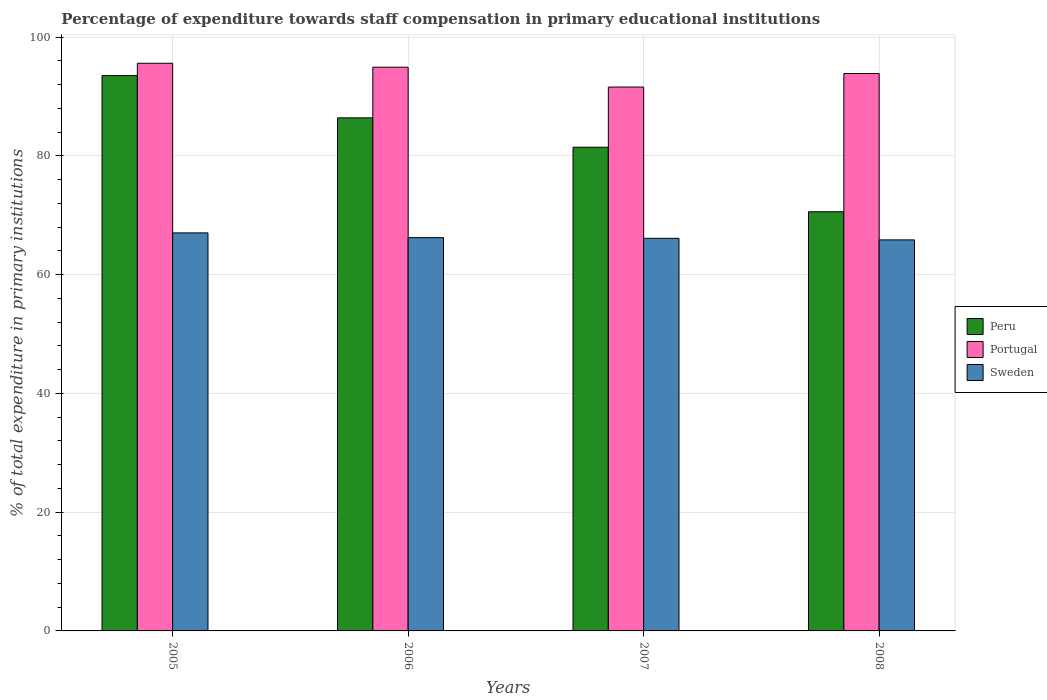How many different coloured bars are there?
Give a very brief answer. 3. Are the number of bars per tick equal to the number of legend labels?
Provide a succinct answer. Yes. Are the number of bars on each tick of the X-axis equal?
Your answer should be very brief. Yes. How many bars are there on the 4th tick from the left?
Keep it short and to the point. 3. What is the percentage of expenditure towards staff compensation in Sweden in 2006?
Ensure brevity in your answer.  66.23. Across all years, what is the maximum percentage of expenditure towards staff compensation in Portugal?
Offer a terse response. 95.6. Across all years, what is the minimum percentage of expenditure towards staff compensation in Sweden?
Offer a terse response. 65.85. In which year was the percentage of expenditure towards staff compensation in Portugal minimum?
Provide a succinct answer. 2007. What is the total percentage of expenditure towards staff compensation in Peru in the graph?
Make the answer very short. 331.96. What is the difference between the percentage of expenditure towards staff compensation in Peru in 2005 and that in 2008?
Make the answer very short. 22.92. What is the difference between the percentage of expenditure towards staff compensation in Sweden in 2008 and the percentage of expenditure towards staff compensation in Portugal in 2006?
Make the answer very short. -29.08. What is the average percentage of expenditure towards staff compensation in Peru per year?
Provide a succinct answer. 82.99. In the year 2005, what is the difference between the percentage of expenditure towards staff compensation in Peru and percentage of expenditure towards staff compensation in Portugal?
Offer a terse response. -2.09. What is the ratio of the percentage of expenditure towards staff compensation in Peru in 2005 to that in 2006?
Ensure brevity in your answer.  1.08. What is the difference between the highest and the second highest percentage of expenditure towards staff compensation in Portugal?
Make the answer very short. 0.66. What is the difference between the highest and the lowest percentage of expenditure towards staff compensation in Portugal?
Give a very brief answer. 4.01. Is the sum of the percentage of expenditure towards staff compensation in Peru in 2005 and 2007 greater than the maximum percentage of expenditure towards staff compensation in Sweden across all years?
Offer a terse response. Yes. What does the 3rd bar from the left in 2005 represents?
Ensure brevity in your answer.  Sweden. Is it the case that in every year, the sum of the percentage of expenditure towards staff compensation in Peru and percentage of expenditure towards staff compensation in Sweden is greater than the percentage of expenditure towards staff compensation in Portugal?
Give a very brief answer. Yes. How many years are there in the graph?
Ensure brevity in your answer.  4. What is the difference between two consecutive major ticks on the Y-axis?
Offer a terse response. 20. Does the graph contain any zero values?
Your response must be concise. No. Where does the legend appear in the graph?
Give a very brief answer. Center right. How many legend labels are there?
Provide a short and direct response. 3. What is the title of the graph?
Provide a short and direct response. Percentage of expenditure towards staff compensation in primary educational institutions. Does "Guinea" appear as one of the legend labels in the graph?
Provide a succinct answer. No. What is the label or title of the X-axis?
Provide a short and direct response. Years. What is the label or title of the Y-axis?
Give a very brief answer. % of total expenditure in primary institutions. What is the % of total expenditure in primary institutions of Peru in 2005?
Make the answer very short. 93.51. What is the % of total expenditure in primary institutions of Portugal in 2005?
Your response must be concise. 95.6. What is the % of total expenditure in primary institutions of Sweden in 2005?
Your response must be concise. 67.03. What is the % of total expenditure in primary institutions in Peru in 2006?
Your answer should be compact. 86.4. What is the % of total expenditure in primary institutions of Portugal in 2006?
Keep it short and to the point. 94.93. What is the % of total expenditure in primary institutions of Sweden in 2006?
Provide a short and direct response. 66.23. What is the % of total expenditure in primary institutions of Peru in 2007?
Offer a very short reply. 81.46. What is the % of total expenditure in primary institutions in Portugal in 2007?
Make the answer very short. 91.59. What is the % of total expenditure in primary institutions in Sweden in 2007?
Give a very brief answer. 66.11. What is the % of total expenditure in primary institutions of Peru in 2008?
Your answer should be compact. 70.59. What is the % of total expenditure in primary institutions of Portugal in 2008?
Your response must be concise. 93.87. What is the % of total expenditure in primary institutions of Sweden in 2008?
Keep it short and to the point. 65.85. Across all years, what is the maximum % of total expenditure in primary institutions of Peru?
Make the answer very short. 93.51. Across all years, what is the maximum % of total expenditure in primary institutions in Portugal?
Offer a terse response. 95.6. Across all years, what is the maximum % of total expenditure in primary institutions in Sweden?
Keep it short and to the point. 67.03. Across all years, what is the minimum % of total expenditure in primary institutions of Peru?
Ensure brevity in your answer.  70.59. Across all years, what is the minimum % of total expenditure in primary institutions in Portugal?
Your answer should be very brief. 91.59. Across all years, what is the minimum % of total expenditure in primary institutions in Sweden?
Offer a terse response. 65.85. What is the total % of total expenditure in primary institutions of Peru in the graph?
Provide a succinct answer. 331.96. What is the total % of total expenditure in primary institutions of Portugal in the graph?
Provide a succinct answer. 375.99. What is the total % of total expenditure in primary institutions in Sweden in the graph?
Keep it short and to the point. 265.23. What is the difference between the % of total expenditure in primary institutions in Peru in 2005 and that in 2006?
Make the answer very short. 7.11. What is the difference between the % of total expenditure in primary institutions of Portugal in 2005 and that in 2006?
Your answer should be compact. 0.66. What is the difference between the % of total expenditure in primary institutions of Sweden in 2005 and that in 2006?
Provide a short and direct response. 0.8. What is the difference between the % of total expenditure in primary institutions in Peru in 2005 and that in 2007?
Ensure brevity in your answer.  12.06. What is the difference between the % of total expenditure in primary institutions of Portugal in 2005 and that in 2007?
Offer a terse response. 4.01. What is the difference between the % of total expenditure in primary institutions of Sweden in 2005 and that in 2007?
Provide a short and direct response. 0.92. What is the difference between the % of total expenditure in primary institutions in Peru in 2005 and that in 2008?
Provide a short and direct response. 22.92. What is the difference between the % of total expenditure in primary institutions in Portugal in 2005 and that in 2008?
Provide a succinct answer. 1.73. What is the difference between the % of total expenditure in primary institutions in Sweden in 2005 and that in 2008?
Your response must be concise. 1.18. What is the difference between the % of total expenditure in primary institutions of Peru in 2006 and that in 2007?
Your answer should be very brief. 4.95. What is the difference between the % of total expenditure in primary institutions of Portugal in 2006 and that in 2007?
Your answer should be very brief. 3.35. What is the difference between the % of total expenditure in primary institutions in Sweden in 2006 and that in 2007?
Your answer should be compact. 0.12. What is the difference between the % of total expenditure in primary institutions of Peru in 2006 and that in 2008?
Your answer should be compact. 15.81. What is the difference between the % of total expenditure in primary institutions in Portugal in 2006 and that in 2008?
Your answer should be very brief. 1.06. What is the difference between the % of total expenditure in primary institutions in Sweden in 2006 and that in 2008?
Ensure brevity in your answer.  0.38. What is the difference between the % of total expenditure in primary institutions of Peru in 2007 and that in 2008?
Make the answer very short. 10.87. What is the difference between the % of total expenditure in primary institutions in Portugal in 2007 and that in 2008?
Offer a very short reply. -2.28. What is the difference between the % of total expenditure in primary institutions of Sweden in 2007 and that in 2008?
Give a very brief answer. 0.26. What is the difference between the % of total expenditure in primary institutions in Peru in 2005 and the % of total expenditure in primary institutions in Portugal in 2006?
Offer a terse response. -1.42. What is the difference between the % of total expenditure in primary institutions of Peru in 2005 and the % of total expenditure in primary institutions of Sweden in 2006?
Your response must be concise. 27.28. What is the difference between the % of total expenditure in primary institutions in Portugal in 2005 and the % of total expenditure in primary institutions in Sweden in 2006?
Your answer should be compact. 29.37. What is the difference between the % of total expenditure in primary institutions of Peru in 2005 and the % of total expenditure in primary institutions of Portugal in 2007?
Provide a short and direct response. 1.92. What is the difference between the % of total expenditure in primary institutions in Peru in 2005 and the % of total expenditure in primary institutions in Sweden in 2007?
Offer a very short reply. 27.4. What is the difference between the % of total expenditure in primary institutions in Portugal in 2005 and the % of total expenditure in primary institutions in Sweden in 2007?
Your response must be concise. 29.48. What is the difference between the % of total expenditure in primary institutions of Peru in 2005 and the % of total expenditure in primary institutions of Portugal in 2008?
Provide a succinct answer. -0.36. What is the difference between the % of total expenditure in primary institutions in Peru in 2005 and the % of total expenditure in primary institutions in Sweden in 2008?
Give a very brief answer. 27.66. What is the difference between the % of total expenditure in primary institutions of Portugal in 2005 and the % of total expenditure in primary institutions of Sweden in 2008?
Your answer should be compact. 29.74. What is the difference between the % of total expenditure in primary institutions of Peru in 2006 and the % of total expenditure in primary institutions of Portugal in 2007?
Provide a short and direct response. -5.18. What is the difference between the % of total expenditure in primary institutions in Peru in 2006 and the % of total expenditure in primary institutions in Sweden in 2007?
Make the answer very short. 20.29. What is the difference between the % of total expenditure in primary institutions in Portugal in 2006 and the % of total expenditure in primary institutions in Sweden in 2007?
Offer a very short reply. 28.82. What is the difference between the % of total expenditure in primary institutions in Peru in 2006 and the % of total expenditure in primary institutions in Portugal in 2008?
Your response must be concise. -7.47. What is the difference between the % of total expenditure in primary institutions of Peru in 2006 and the % of total expenditure in primary institutions of Sweden in 2008?
Make the answer very short. 20.55. What is the difference between the % of total expenditure in primary institutions of Portugal in 2006 and the % of total expenditure in primary institutions of Sweden in 2008?
Provide a short and direct response. 29.08. What is the difference between the % of total expenditure in primary institutions in Peru in 2007 and the % of total expenditure in primary institutions in Portugal in 2008?
Offer a terse response. -12.41. What is the difference between the % of total expenditure in primary institutions of Peru in 2007 and the % of total expenditure in primary institutions of Sweden in 2008?
Offer a very short reply. 15.6. What is the difference between the % of total expenditure in primary institutions of Portugal in 2007 and the % of total expenditure in primary institutions of Sweden in 2008?
Give a very brief answer. 25.73. What is the average % of total expenditure in primary institutions of Peru per year?
Provide a short and direct response. 82.99. What is the average % of total expenditure in primary institutions in Portugal per year?
Provide a short and direct response. 94. What is the average % of total expenditure in primary institutions of Sweden per year?
Your answer should be compact. 66.31. In the year 2005, what is the difference between the % of total expenditure in primary institutions of Peru and % of total expenditure in primary institutions of Portugal?
Keep it short and to the point. -2.09. In the year 2005, what is the difference between the % of total expenditure in primary institutions of Peru and % of total expenditure in primary institutions of Sweden?
Keep it short and to the point. 26.48. In the year 2005, what is the difference between the % of total expenditure in primary institutions in Portugal and % of total expenditure in primary institutions in Sweden?
Give a very brief answer. 28.57. In the year 2006, what is the difference between the % of total expenditure in primary institutions in Peru and % of total expenditure in primary institutions in Portugal?
Ensure brevity in your answer.  -8.53. In the year 2006, what is the difference between the % of total expenditure in primary institutions in Peru and % of total expenditure in primary institutions in Sweden?
Ensure brevity in your answer.  20.17. In the year 2006, what is the difference between the % of total expenditure in primary institutions of Portugal and % of total expenditure in primary institutions of Sweden?
Keep it short and to the point. 28.7. In the year 2007, what is the difference between the % of total expenditure in primary institutions of Peru and % of total expenditure in primary institutions of Portugal?
Keep it short and to the point. -10.13. In the year 2007, what is the difference between the % of total expenditure in primary institutions of Peru and % of total expenditure in primary institutions of Sweden?
Your answer should be very brief. 15.34. In the year 2007, what is the difference between the % of total expenditure in primary institutions of Portugal and % of total expenditure in primary institutions of Sweden?
Offer a terse response. 25.47. In the year 2008, what is the difference between the % of total expenditure in primary institutions of Peru and % of total expenditure in primary institutions of Portugal?
Provide a short and direct response. -23.28. In the year 2008, what is the difference between the % of total expenditure in primary institutions in Peru and % of total expenditure in primary institutions in Sweden?
Give a very brief answer. 4.74. In the year 2008, what is the difference between the % of total expenditure in primary institutions of Portugal and % of total expenditure in primary institutions of Sweden?
Your response must be concise. 28.02. What is the ratio of the % of total expenditure in primary institutions of Peru in 2005 to that in 2006?
Ensure brevity in your answer.  1.08. What is the ratio of the % of total expenditure in primary institutions in Sweden in 2005 to that in 2006?
Offer a terse response. 1.01. What is the ratio of the % of total expenditure in primary institutions of Peru in 2005 to that in 2007?
Your answer should be very brief. 1.15. What is the ratio of the % of total expenditure in primary institutions of Portugal in 2005 to that in 2007?
Keep it short and to the point. 1.04. What is the ratio of the % of total expenditure in primary institutions in Sweden in 2005 to that in 2007?
Ensure brevity in your answer.  1.01. What is the ratio of the % of total expenditure in primary institutions of Peru in 2005 to that in 2008?
Keep it short and to the point. 1.32. What is the ratio of the % of total expenditure in primary institutions of Portugal in 2005 to that in 2008?
Give a very brief answer. 1.02. What is the ratio of the % of total expenditure in primary institutions in Sweden in 2005 to that in 2008?
Give a very brief answer. 1.02. What is the ratio of the % of total expenditure in primary institutions of Peru in 2006 to that in 2007?
Keep it short and to the point. 1.06. What is the ratio of the % of total expenditure in primary institutions of Portugal in 2006 to that in 2007?
Offer a terse response. 1.04. What is the ratio of the % of total expenditure in primary institutions in Sweden in 2006 to that in 2007?
Ensure brevity in your answer.  1. What is the ratio of the % of total expenditure in primary institutions of Peru in 2006 to that in 2008?
Make the answer very short. 1.22. What is the ratio of the % of total expenditure in primary institutions of Portugal in 2006 to that in 2008?
Keep it short and to the point. 1.01. What is the ratio of the % of total expenditure in primary institutions in Peru in 2007 to that in 2008?
Keep it short and to the point. 1.15. What is the ratio of the % of total expenditure in primary institutions of Portugal in 2007 to that in 2008?
Ensure brevity in your answer.  0.98. What is the difference between the highest and the second highest % of total expenditure in primary institutions of Peru?
Ensure brevity in your answer.  7.11. What is the difference between the highest and the second highest % of total expenditure in primary institutions in Portugal?
Your answer should be compact. 0.66. What is the difference between the highest and the second highest % of total expenditure in primary institutions in Sweden?
Your response must be concise. 0.8. What is the difference between the highest and the lowest % of total expenditure in primary institutions in Peru?
Provide a succinct answer. 22.92. What is the difference between the highest and the lowest % of total expenditure in primary institutions of Portugal?
Give a very brief answer. 4.01. What is the difference between the highest and the lowest % of total expenditure in primary institutions in Sweden?
Your response must be concise. 1.18. 